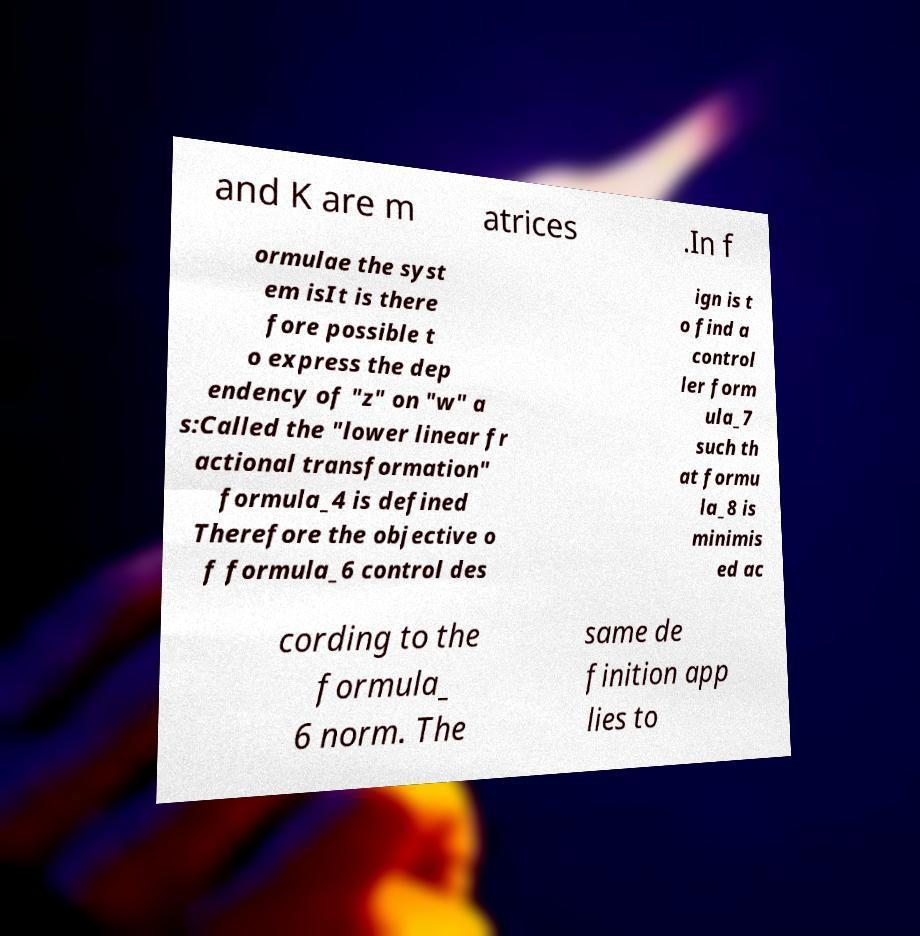Can you read and provide the text displayed in the image?This photo seems to have some interesting text. Can you extract and type it out for me? and K are m atrices .In f ormulae the syst em isIt is there fore possible t o express the dep endency of "z" on "w" a s:Called the "lower linear fr actional transformation" formula_4 is defined Therefore the objective o f formula_6 control des ign is t o find a control ler form ula_7 such th at formu la_8 is minimis ed ac cording to the formula_ 6 norm. The same de finition app lies to 